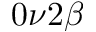<formula> <loc_0><loc_0><loc_500><loc_500>0 \nu 2 \beta</formula> 